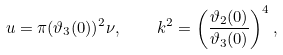<formula> <loc_0><loc_0><loc_500><loc_500>u = \pi ( \vartheta _ { 3 } ( 0 ) ) ^ { 2 } \nu , \quad k ^ { 2 } = \left ( \frac { \vartheta _ { 2 } ( 0 ) } { \vartheta _ { 3 } ( 0 ) } \right ) ^ { 4 } ,</formula> 